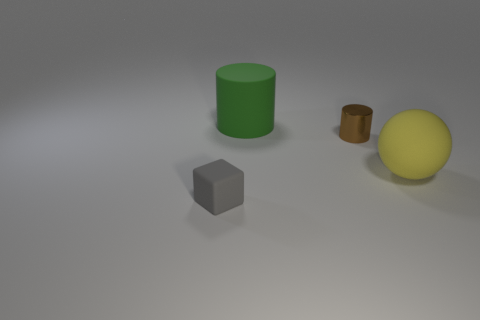Does the rubber object that is behind the yellow matte object have the same size as the tiny gray rubber object?
Your response must be concise. No. Is there a metallic object?
Offer a terse response. Yes. There is a green thing that is the same material as the gray thing; what is its shape?
Your response must be concise. Cylinder. There is a green matte object; does it have the same shape as the thing that is right of the small shiny cylinder?
Your response must be concise. No. What is the material of the cylinder that is behind the small thing on the right side of the tiny gray matte block?
Offer a very short reply. Rubber. What number of other things are the same shape as the yellow matte thing?
Offer a terse response. 0. Do the small object that is on the right side of the gray object and the large object that is in front of the tiny shiny cylinder have the same shape?
Provide a short and direct response. No. Are there any other things that have the same material as the brown object?
Your answer should be very brief. No. What is the small gray block made of?
Ensure brevity in your answer.  Rubber. What is the material of the big object that is behind the yellow ball?
Provide a succinct answer. Rubber. 